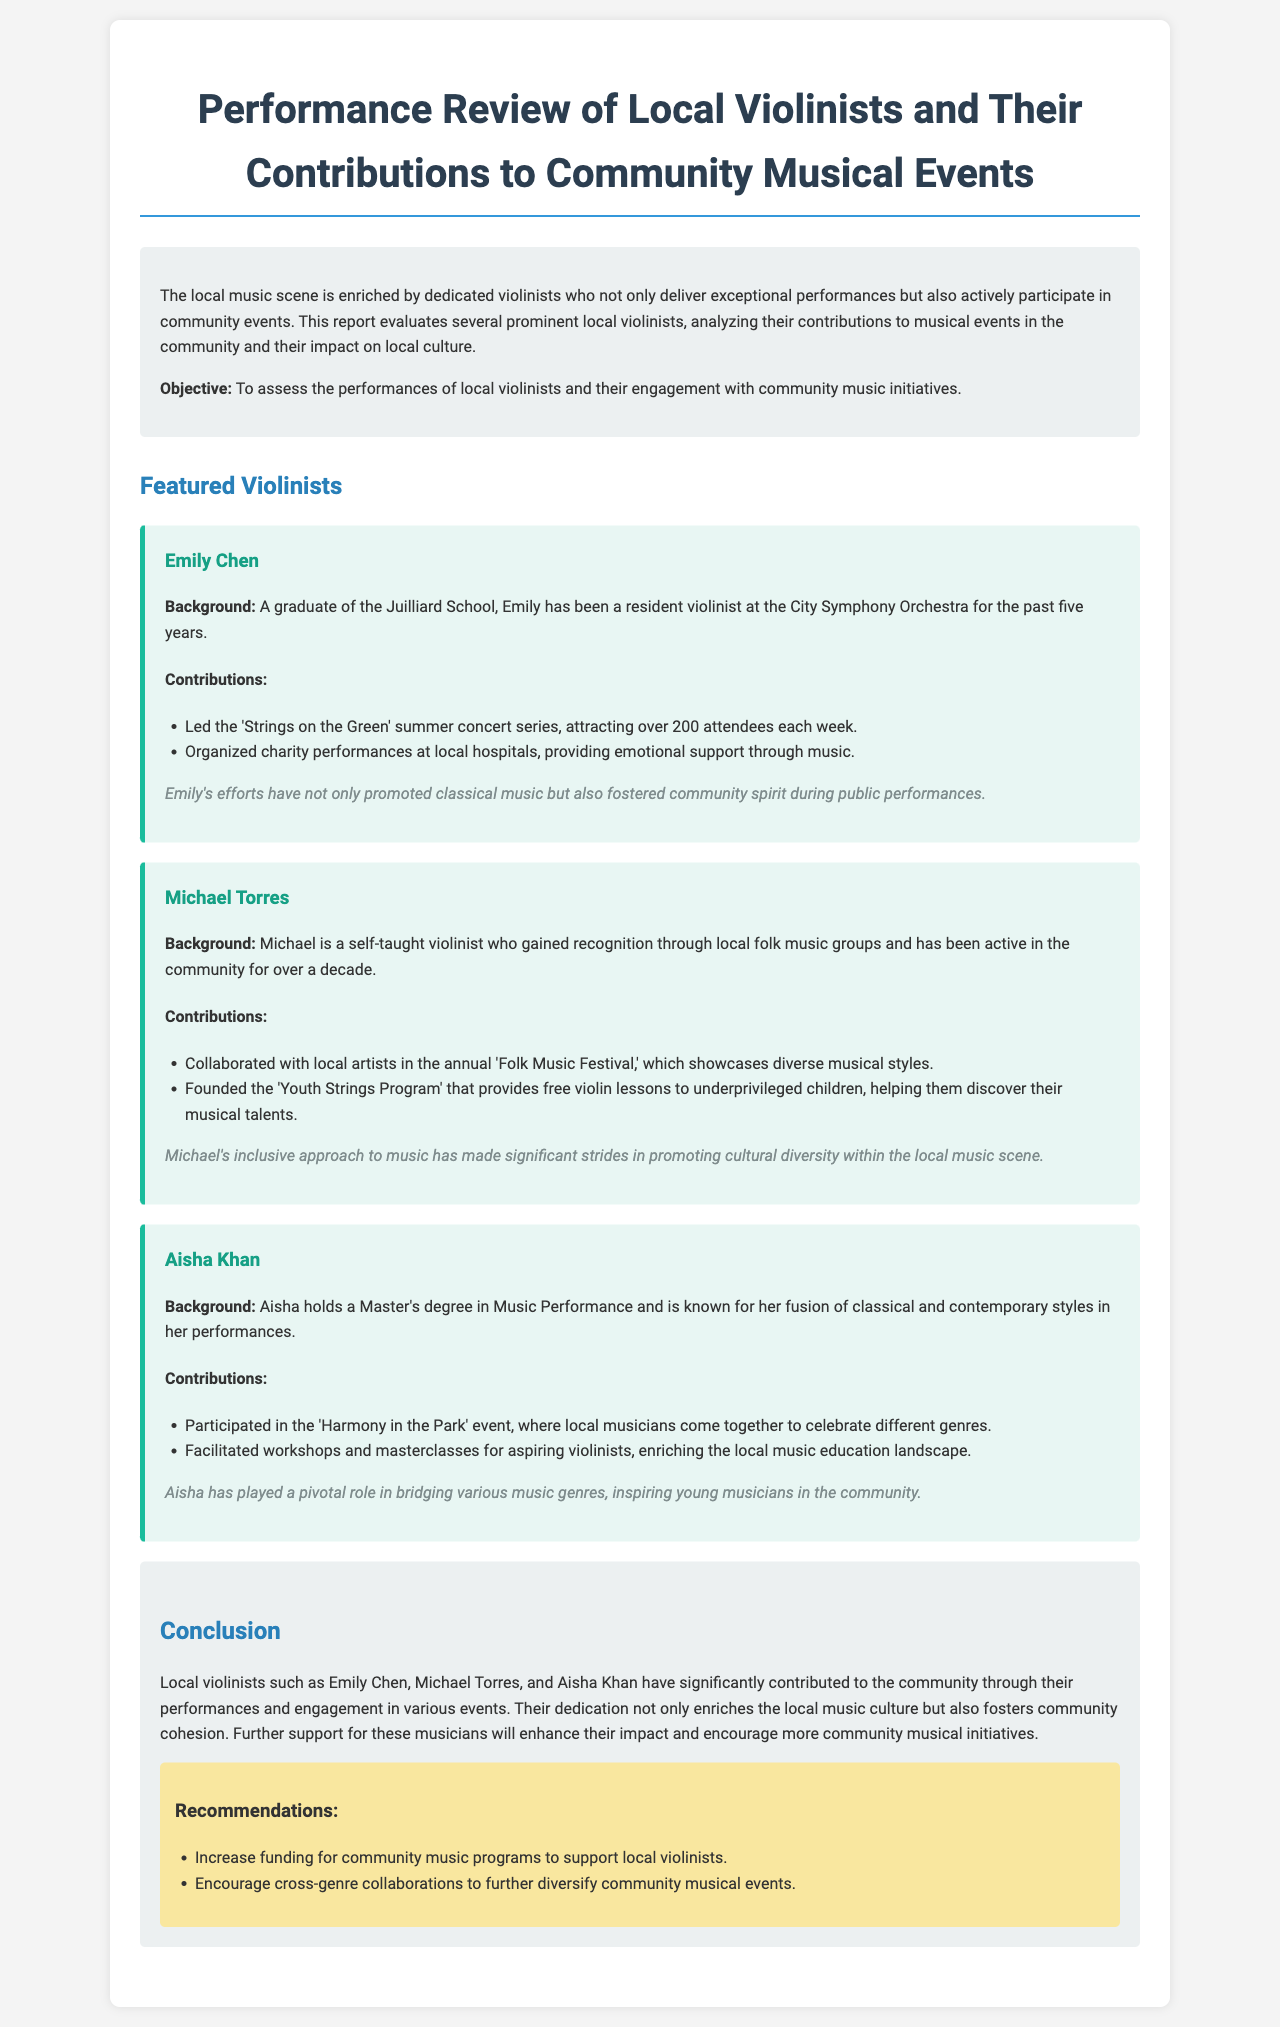What is the title of the report? The title of the report summarizes the evaluation of local violinists and their contributions to musical events, as stated at the beginning of the document.
Answer: Performance Review of Local Violinists and Their Contributions to Community Musical Events Who is the first featured violinist? The report introduces several violinists, starting with Emily Chen.
Answer: Emily Chen How long has Michael Torres been active in the community? The document specifies that Michael Torres has been active in the community for over a decade.
Answer: Over a decade What notable event did Aisha Khan participate in? Aisha Khan is noted for her involvement in the 'Harmony in the Park' event, as detailed in her contributions.
Answer: Harmony in the Park What is one of Emily Chen's contributions to the community? The report lists Emily's leading role in the 'Strings on the Green' summer concert series as a significant contribution.
Answer: Led the 'Strings on the Green' summer concert series What type of program did Michael Torres found? The report indicates that Michael founded the 'Youth Strings Program' to help underprivileged children.
Answer: Youth Strings Program What is a recommendation made in the conclusion? The conclusion includes recommendations, one of which is to increase funding for community music programs.
Answer: Increase funding for community music programs What background does Aisha Khan have? The document states that Aisha holds a Master's degree in Music Performance, summarizing her educational qualifications.
Answer: Master's degree in Music Performance 